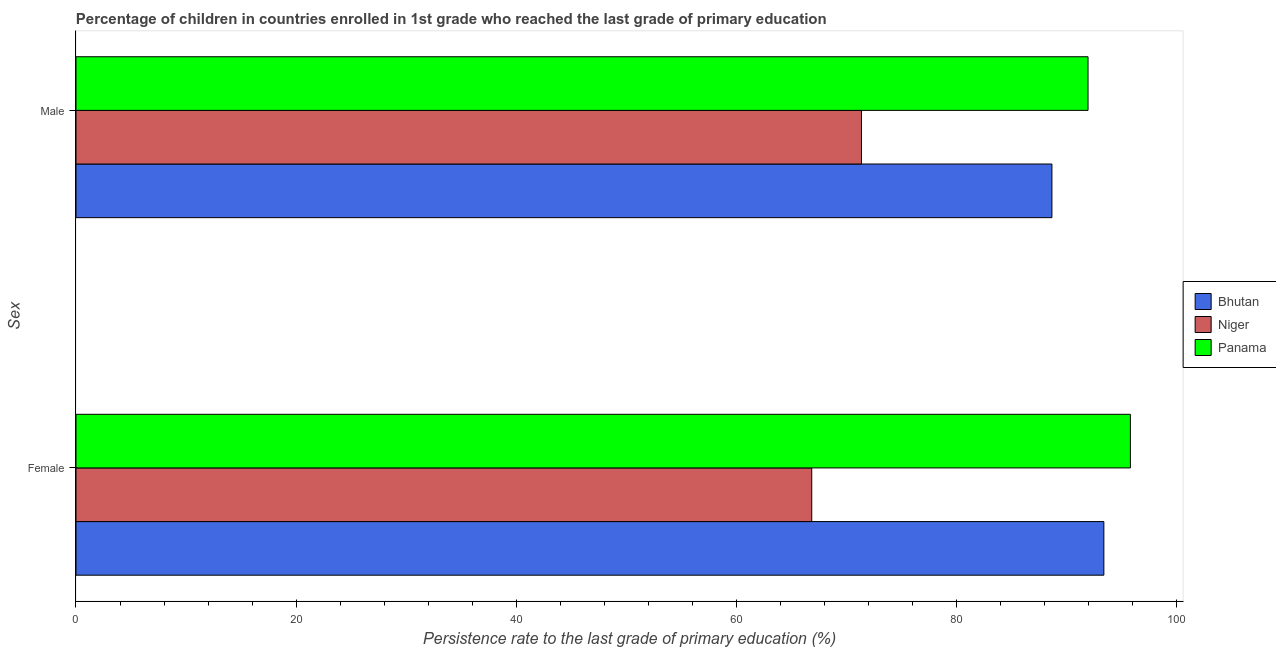How many different coloured bars are there?
Give a very brief answer. 3. Are the number of bars on each tick of the Y-axis equal?
Offer a terse response. Yes. How many bars are there on the 1st tick from the top?
Your answer should be very brief. 3. What is the persistence rate of male students in Niger?
Your answer should be compact. 71.39. Across all countries, what is the maximum persistence rate of male students?
Provide a succinct answer. 91.99. Across all countries, what is the minimum persistence rate of female students?
Keep it short and to the point. 66.87. In which country was the persistence rate of female students maximum?
Provide a short and direct response. Panama. In which country was the persistence rate of female students minimum?
Your answer should be very brief. Niger. What is the total persistence rate of female students in the graph?
Provide a succinct answer. 256.14. What is the difference between the persistence rate of male students in Panama and that in Bhutan?
Provide a short and direct response. 3.28. What is the difference between the persistence rate of female students in Panama and the persistence rate of male students in Bhutan?
Give a very brief answer. 7.13. What is the average persistence rate of male students per country?
Ensure brevity in your answer.  84.03. What is the difference between the persistence rate of male students and persistence rate of female students in Bhutan?
Offer a terse response. -4.72. What is the ratio of the persistence rate of male students in Bhutan to that in Panama?
Keep it short and to the point. 0.96. In how many countries, is the persistence rate of male students greater than the average persistence rate of male students taken over all countries?
Give a very brief answer. 2. What does the 2nd bar from the top in Female represents?
Offer a very short reply. Niger. What does the 3rd bar from the bottom in Male represents?
Make the answer very short. Panama. Are all the bars in the graph horizontal?
Provide a succinct answer. Yes. Does the graph contain grids?
Provide a succinct answer. No. How many legend labels are there?
Provide a succinct answer. 3. How are the legend labels stacked?
Your response must be concise. Vertical. What is the title of the graph?
Your response must be concise. Percentage of children in countries enrolled in 1st grade who reached the last grade of primary education. Does "Slovak Republic" appear as one of the legend labels in the graph?
Give a very brief answer. No. What is the label or title of the X-axis?
Make the answer very short. Persistence rate to the last grade of primary education (%). What is the label or title of the Y-axis?
Keep it short and to the point. Sex. What is the Persistence rate to the last grade of primary education (%) in Bhutan in Female?
Your response must be concise. 93.43. What is the Persistence rate to the last grade of primary education (%) in Niger in Female?
Offer a very short reply. 66.87. What is the Persistence rate to the last grade of primary education (%) in Panama in Female?
Provide a succinct answer. 95.84. What is the Persistence rate to the last grade of primary education (%) of Bhutan in Male?
Make the answer very short. 88.7. What is the Persistence rate to the last grade of primary education (%) in Niger in Male?
Your answer should be compact. 71.39. What is the Persistence rate to the last grade of primary education (%) of Panama in Male?
Your answer should be very brief. 91.99. Across all Sex, what is the maximum Persistence rate to the last grade of primary education (%) in Bhutan?
Ensure brevity in your answer.  93.43. Across all Sex, what is the maximum Persistence rate to the last grade of primary education (%) of Niger?
Make the answer very short. 71.39. Across all Sex, what is the maximum Persistence rate to the last grade of primary education (%) in Panama?
Your response must be concise. 95.84. Across all Sex, what is the minimum Persistence rate to the last grade of primary education (%) in Bhutan?
Provide a succinct answer. 88.7. Across all Sex, what is the minimum Persistence rate to the last grade of primary education (%) in Niger?
Give a very brief answer. 66.87. Across all Sex, what is the minimum Persistence rate to the last grade of primary education (%) of Panama?
Offer a terse response. 91.99. What is the total Persistence rate to the last grade of primary education (%) in Bhutan in the graph?
Provide a short and direct response. 182.13. What is the total Persistence rate to the last grade of primary education (%) of Niger in the graph?
Provide a succinct answer. 138.27. What is the total Persistence rate to the last grade of primary education (%) of Panama in the graph?
Your answer should be compact. 187.82. What is the difference between the Persistence rate to the last grade of primary education (%) in Bhutan in Female and that in Male?
Ensure brevity in your answer.  4.72. What is the difference between the Persistence rate to the last grade of primary education (%) in Niger in Female and that in Male?
Ensure brevity in your answer.  -4.52. What is the difference between the Persistence rate to the last grade of primary education (%) of Panama in Female and that in Male?
Give a very brief answer. 3.85. What is the difference between the Persistence rate to the last grade of primary education (%) in Bhutan in Female and the Persistence rate to the last grade of primary education (%) in Niger in Male?
Make the answer very short. 22.03. What is the difference between the Persistence rate to the last grade of primary education (%) of Bhutan in Female and the Persistence rate to the last grade of primary education (%) of Panama in Male?
Your answer should be compact. 1.44. What is the difference between the Persistence rate to the last grade of primary education (%) in Niger in Female and the Persistence rate to the last grade of primary education (%) in Panama in Male?
Give a very brief answer. -25.11. What is the average Persistence rate to the last grade of primary education (%) of Bhutan per Sex?
Keep it short and to the point. 91.06. What is the average Persistence rate to the last grade of primary education (%) of Niger per Sex?
Your response must be concise. 69.13. What is the average Persistence rate to the last grade of primary education (%) in Panama per Sex?
Offer a very short reply. 93.91. What is the difference between the Persistence rate to the last grade of primary education (%) of Bhutan and Persistence rate to the last grade of primary education (%) of Niger in Female?
Provide a succinct answer. 26.55. What is the difference between the Persistence rate to the last grade of primary education (%) in Bhutan and Persistence rate to the last grade of primary education (%) in Panama in Female?
Offer a terse response. -2.41. What is the difference between the Persistence rate to the last grade of primary education (%) of Niger and Persistence rate to the last grade of primary education (%) of Panama in Female?
Ensure brevity in your answer.  -28.97. What is the difference between the Persistence rate to the last grade of primary education (%) in Bhutan and Persistence rate to the last grade of primary education (%) in Niger in Male?
Ensure brevity in your answer.  17.31. What is the difference between the Persistence rate to the last grade of primary education (%) in Bhutan and Persistence rate to the last grade of primary education (%) in Panama in Male?
Provide a succinct answer. -3.28. What is the difference between the Persistence rate to the last grade of primary education (%) of Niger and Persistence rate to the last grade of primary education (%) of Panama in Male?
Provide a short and direct response. -20.59. What is the ratio of the Persistence rate to the last grade of primary education (%) of Bhutan in Female to that in Male?
Your answer should be compact. 1.05. What is the ratio of the Persistence rate to the last grade of primary education (%) of Niger in Female to that in Male?
Your answer should be compact. 0.94. What is the ratio of the Persistence rate to the last grade of primary education (%) in Panama in Female to that in Male?
Make the answer very short. 1.04. What is the difference between the highest and the second highest Persistence rate to the last grade of primary education (%) in Bhutan?
Your response must be concise. 4.72. What is the difference between the highest and the second highest Persistence rate to the last grade of primary education (%) of Niger?
Ensure brevity in your answer.  4.52. What is the difference between the highest and the second highest Persistence rate to the last grade of primary education (%) in Panama?
Your answer should be very brief. 3.85. What is the difference between the highest and the lowest Persistence rate to the last grade of primary education (%) in Bhutan?
Offer a very short reply. 4.72. What is the difference between the highest and the lowest Persistence rate to the last grade of primary education (%) in Niger?
Keep it short and to the point. 4.52. What is the difference between the highest and the lowest Persistence rate to the last grade of primary education (%) in Panama?
Provide a short and direct response. 3.85. 